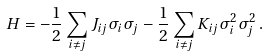<formula> <loc_0><loc_0><loc_500><loc_500>H = - \frac { 1 } { 2 } \sum _ { i \neq j } J _ { i j } \sigma _ { i } \sigma _ { j } - \frac { 1 } { 2 } \sum _ { i \neq j } K _ { i j } \sigma _ { i } ^ { 2 } \sigma _ { j } ^ { 2 } \, .</formula> 